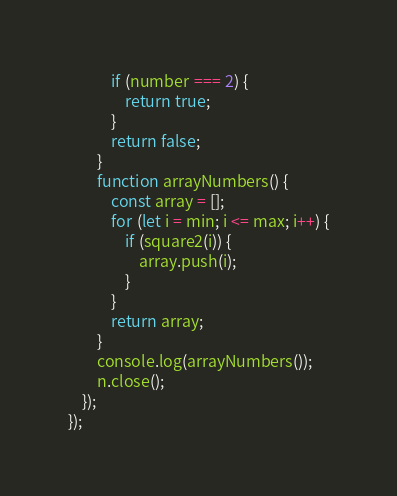Convert code to text. <code><loc_0><loc_0><loc_500><loc_500><_JavaScript_>            if (number === 2) {
                return true;
            }
            return false;
        }
        function arrayNumbers() {
            const array = [];
            for (let i = min; i <= max; i++) {
                if (square2(i)) {
                    array.push(i);
                }
            }
            return array;
        }
        console.log(arrayNumbers());
        n.close();
    });
});
</code> 